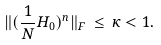Convert formula to latex. <formula><loc_0><loc_0><loc_500><loc_500>\| ( \frac { 1 } { N } H _ { 0 } ) ^ { n } \| _ { F } \, \leq \, \kappa < 1 .</formula> 